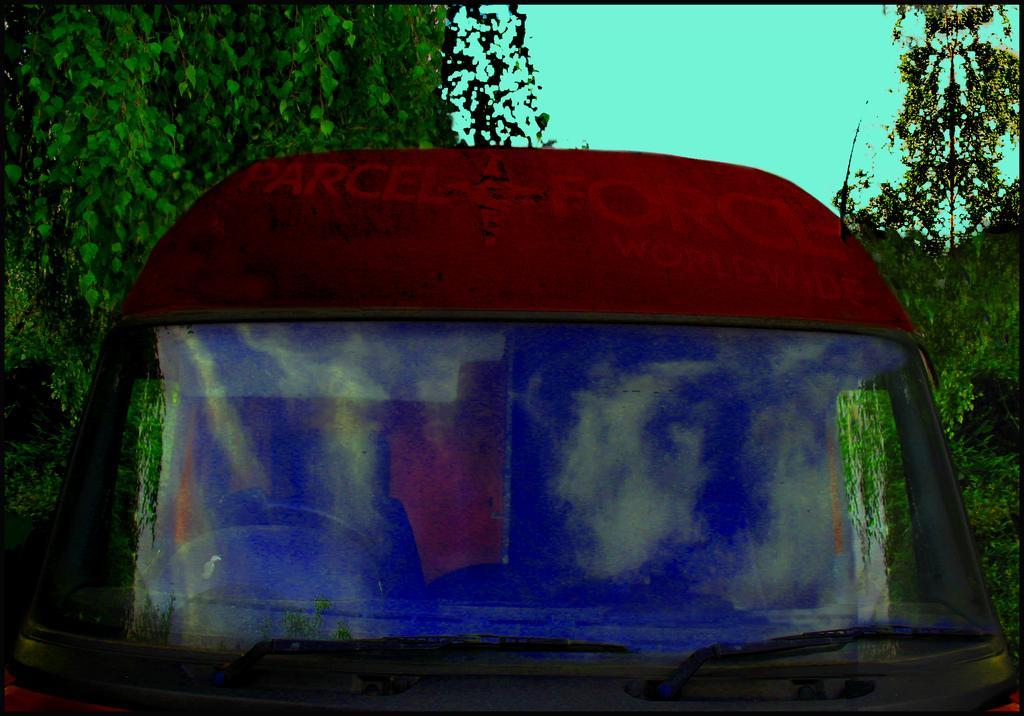Please provide a concise description of this image. In the image we can see there is a vehicle which is in red colour and its front glass is painted. Behind there are trees. 